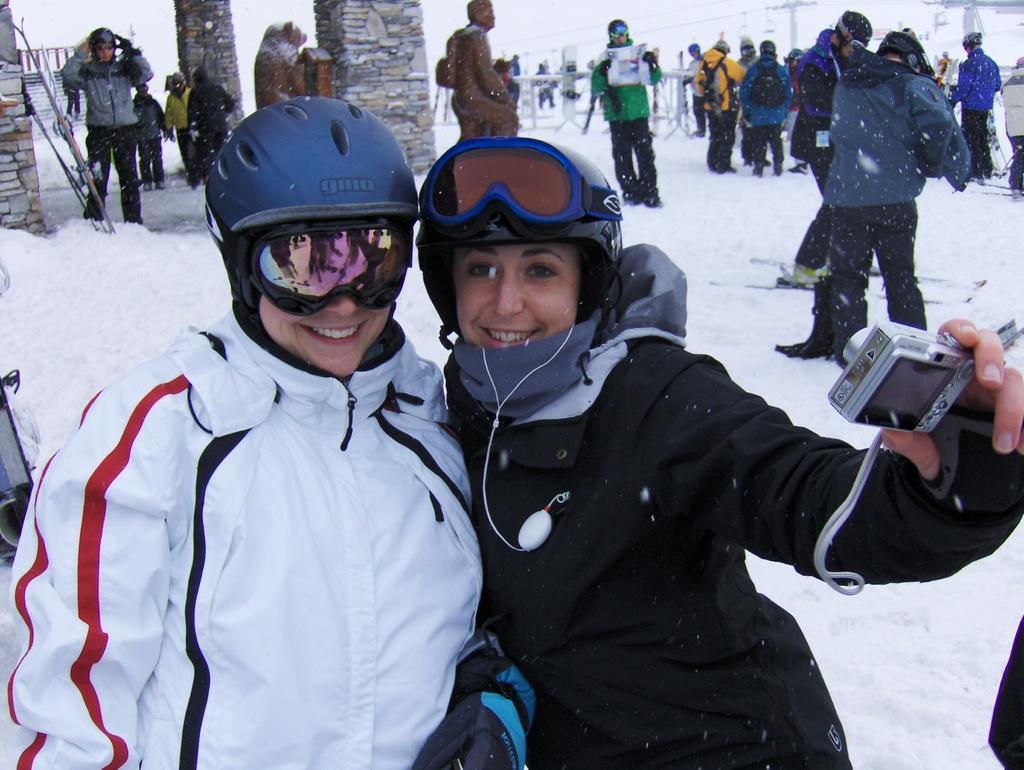Can you describe this image briefly? In this image there are two persons wearing jackets, goggles and helmet. Right side person wearing black jacket is holding a camera in his hand. Few persons are standing on the snow. Left top there are few pillars. Behind it there is a wall. A person holding a paper in his hand. Behind him there is a fence. Right top there are few poles connected with wires. 